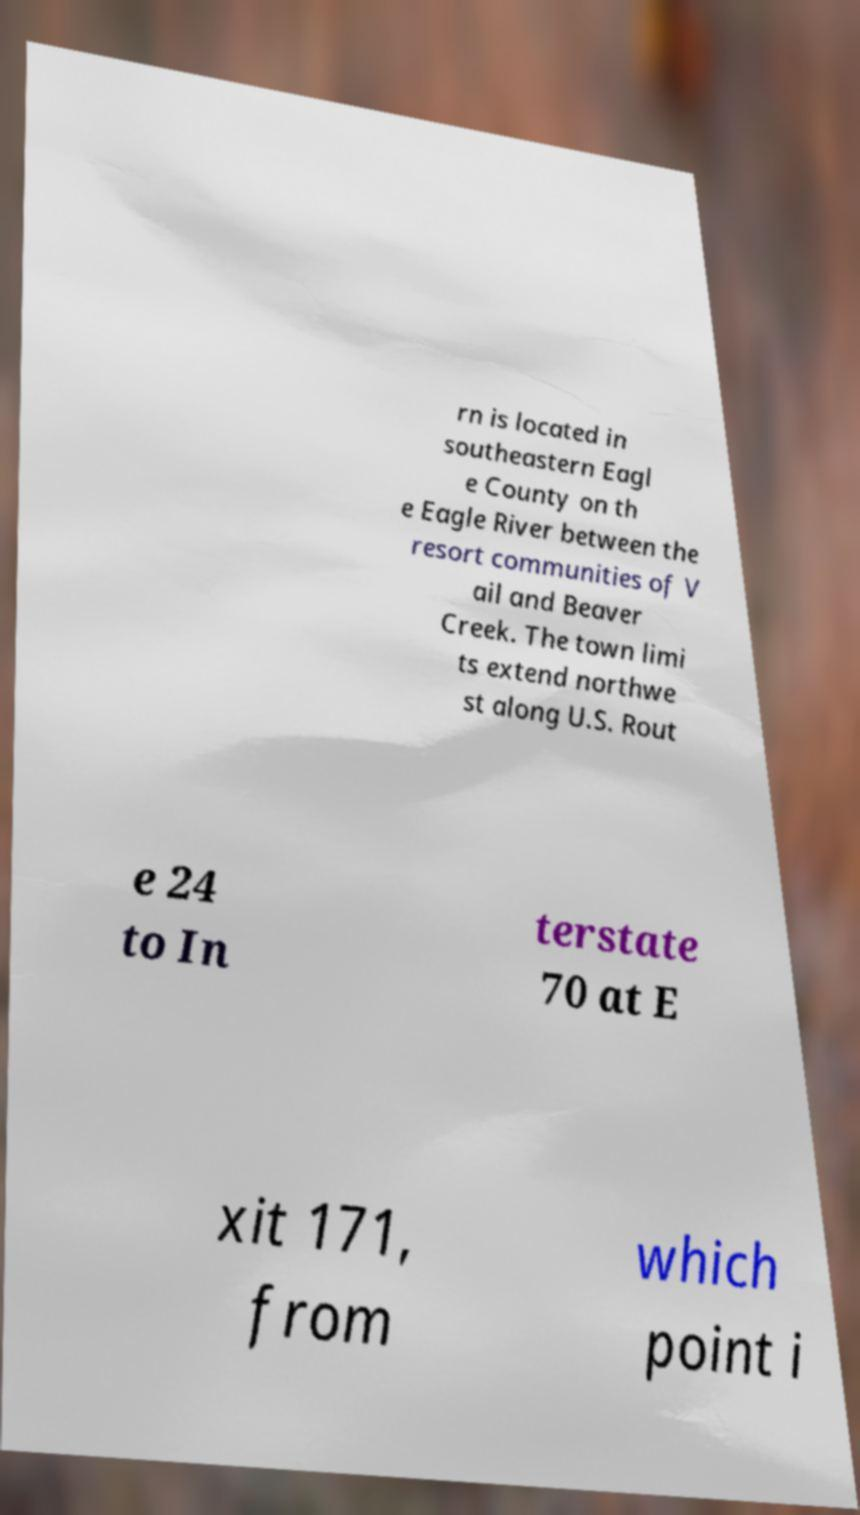Can you read and provide the text displayed in the image?This photo seems to have some interesting text. Can you extract and type it out for me? rn is located in southeastern Eagl e County on th e Eagle River between the resort communities of V ail and Beaver Creek. The town limi ts extend northwe st along U.S. Rout e 24 to In terstate 70 at E xit 171, from which point i 